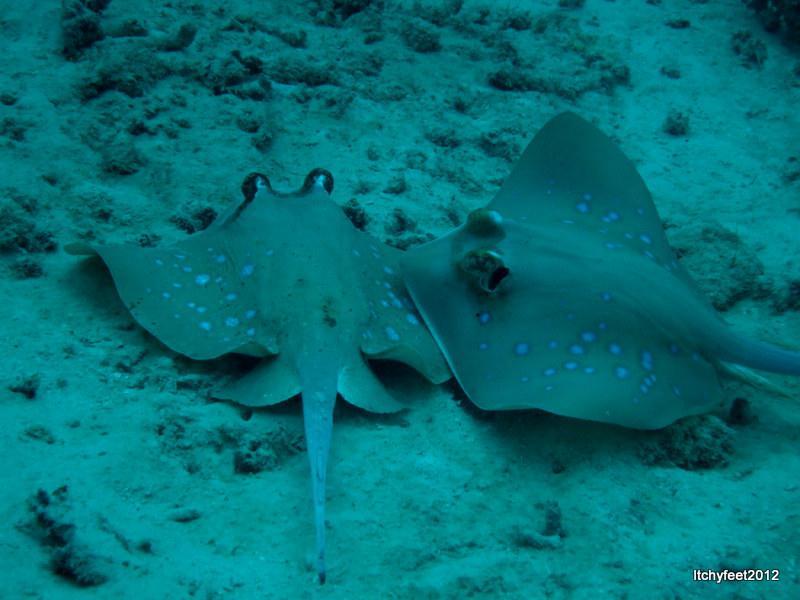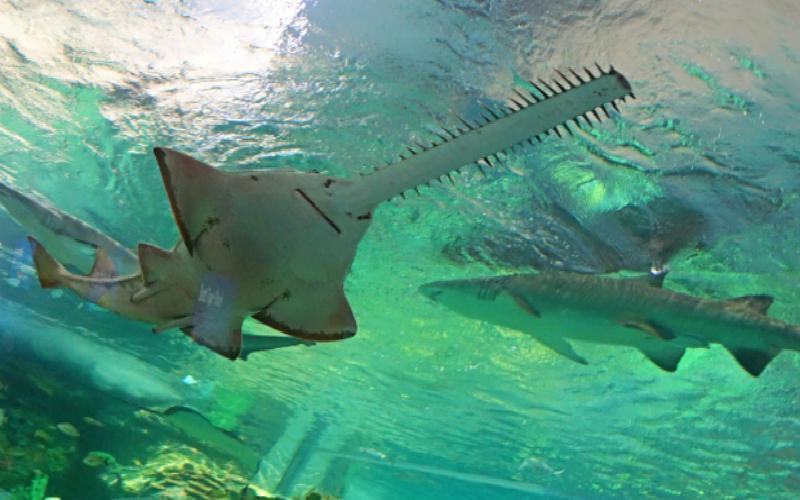The first image is the image on the left, the second image is the image on the right. For the images displayed, is the sentence "In one image there is a lone ray at the bottom of the ocean that has buried itself in the sand." factually correct? Answer yes or no. No. 